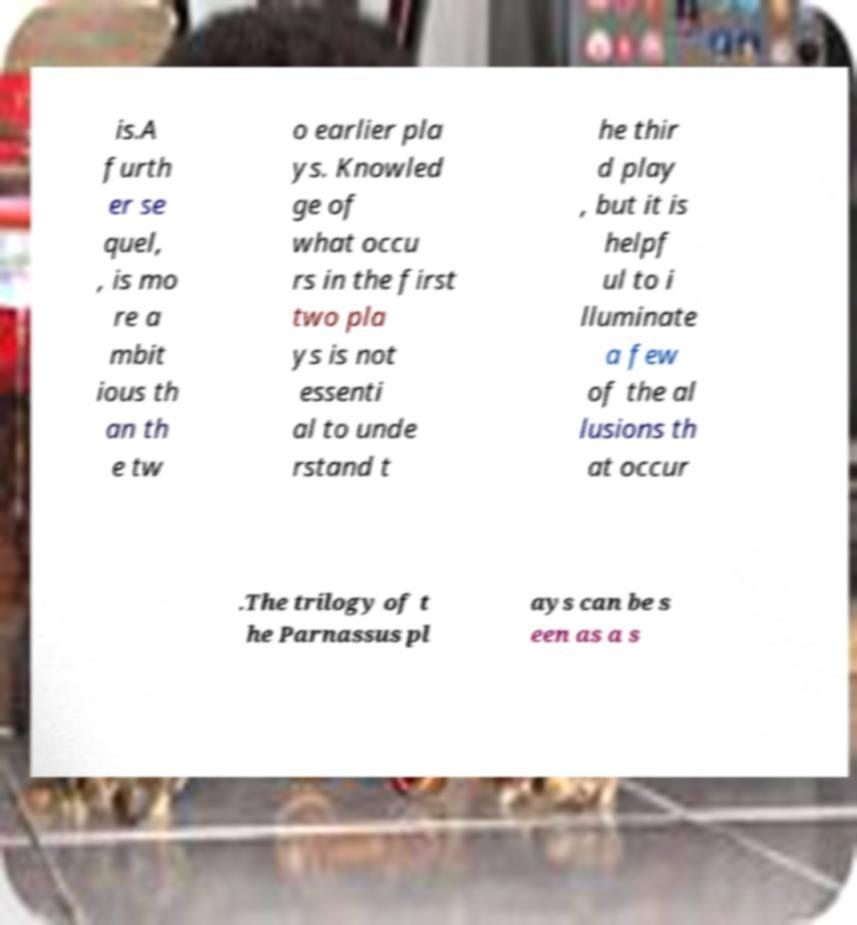Could you assist in decoding the text presented in this image and type it out clearly? is.A furth er se quel, , is mo re a mbit ious th an th e tw o earlier pla ys. Knowled ge of what occu rs in the first two pla ys is not essenti al to unde rstand t he thir d play , but it is helpf ul to i lluminate a few of the al lusions th at occur .The trilogy of t he Parnassus pl ays can be s een as a s 